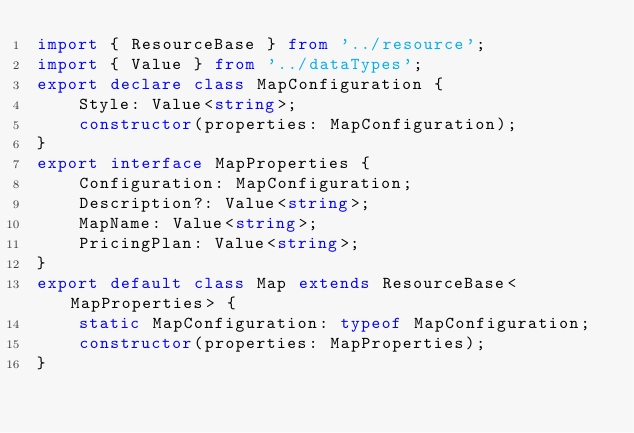<code> <loc_0><loc_0><loc_500><loc_500><_TypeScript_>import { ResourceBase } from '../resource';
import { Value } from '../dataTypes';
export declare class MapConfiguration {
    Style: Value<string>;
    constructor(properties: MapConfiguration);
}
export interface MapProperties {
    Configuration: MapConfiguration;
    Description?: Value<string>;
    MapName: Value<string>;
    PricingPlan: Value<string>;
}
export default class Map extends ResourceBase<MapProperties> {
    static MapConfiguration: typeof MapConfiguration;
    constructor(properties: MapProperties);
}
</code> 